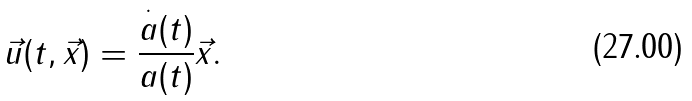<formula> <loc_0><loc_0><loc_500><loc_500>\vec { u } ( t , \vec { x } ) = \frac { \overset { \cdot } { a } ( t ) } { a ( t ) } \vec { x } .</formula> 